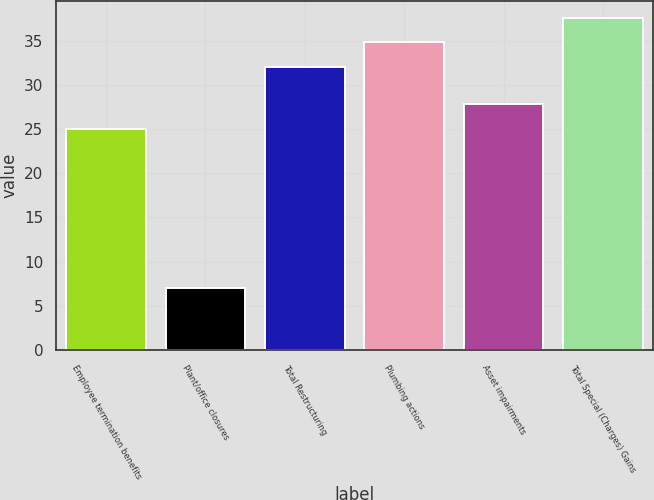Convert chart. <chart><loc_0><loc_0><loc_500><loc_500><bar_chart><fcel>Employee termination benefits<fcel>Plant/office closures<fcel>Total Restructuring<fcel>Plumbing actions<fcel>Asset impairments<fcel>Total Special (Charges) Gains<nl><fcel>25<fcel>7<fcel>32<fcel>34.8<fcel>27.8<fcel>37.6<nl></chart> 